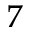<formula> <loc_0><loc_0><loc_500><loc_500>_ { 7 }</formula> 